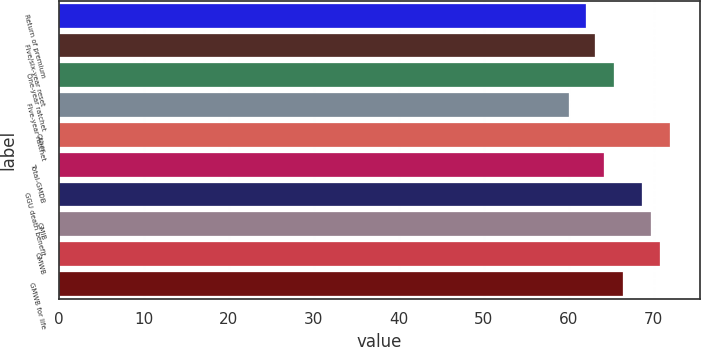<chart> <loc_0><loc_0><loc_500><loc_500><bar_chart><fcel>Return of premium<fcel>Five/six-year reset<fcel>One-year ratchet<fcel>Five-year ratchet<fcel>Other<fcel>Total-GMDB<fcel>GGU death benefit<fcel>GMIB<fcel>GMWB<fcel>GMWB for life<nl><fcel>62<fcel>63.1<fcel>65.3<fcel>60<fcel>71.9<fcel>64.2<fcel>68.6<fcel>69.7<fcel>70.8<fcel>66.4<nl></chart> 